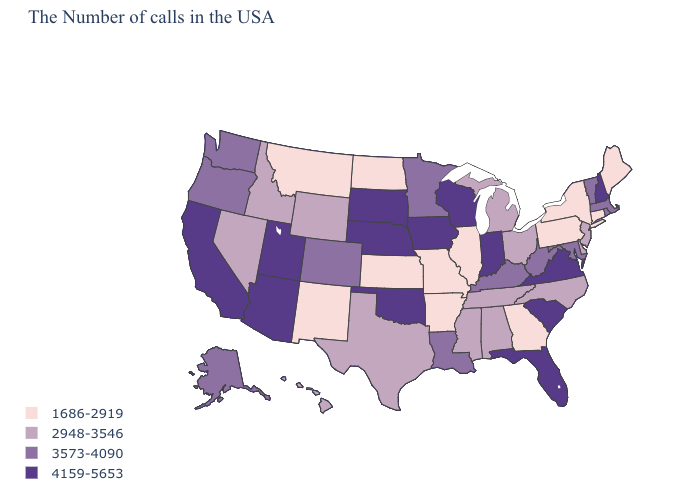Name the states that have a value in the range 1686-2919?
Keep it brief. Maine, Connecticut, New York, Pennsylvania, Georgia, Illinois, Missouri, Arkansas, Kansas, North Dakota, New Mexico, Montana. Among the states that border Vermont , which have the lowest value?
Quick response, please. New York. Which states have the lowest value in the MidWest?
Give a very brief answer. Illinois, Missouri, Kansas, North Dakota. What is the highest value in the West ?
Answer briefly. 4159-5653. Which states hav the highest value in the MidWest?
Concise answer only. Indiana, Wisconsin, Iowa, Nebraska, South Dakota. What is the highest value in states that border New Hampshire?
Answer briefly. 3573-4090. Name the states that have a value in the range 2948-3546?
Short answer required. New Jersey, Delaware, North Carolina, Ohio, Michigan, Alabama, Tennessee, Mississippi, Texas, Wyoming, Idaho, Nevada, Hawaii. Which states have the highest value in the USA?
Keep it brief. New Hampshire, Virginia, South Carolina, Florida, Indiana, Wisconsin, Iowa, Nebraska, Oklahoma, South Dakota, Utah, Arizona, California. Name the states that have a value in the range 2948-3546?
Write a very short answer. New Jersey, Delaware, North Carolina, Ohio, Michigan, Alabama, Tennessee, Mississippi, Texas, Wyoming, Idaho, Nevada, Hawaii. What is the highest value in the South ?
Write a very short answer. 4159-5653. What is the lowest value in states that border Pennsylvania?
Keep it brief. 1686-2919. Name the states that have a value in the range 3573-4090?
Answer briefly. Massachusetts, Rhode Island, Vermont, Maryland, West Virginia, Kentucky, Louisiana, Minnesota, Colorado, Washington, Oregon, Alaska. What is the value of Maine?
Be succinct. 1686-2919. What is the lowest value in the West?
Keep it brief. 1686-2919. What is the value of Vermont?
Be succinct. 3573-4090. 